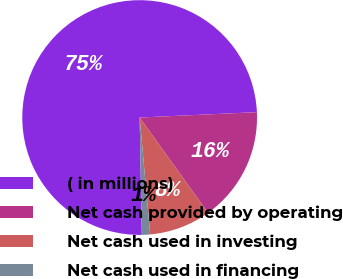Convert chart to OTSL. <chart><loc_0><loc_0><loc_500><loc_500><pie_chart><fcel>( in millions)<fcel>Net cash provided by operating<fcel>Net cash used in investing<fcel>Net cash used in financing<nl><fcel>74.56%<fcel>15.82%<fcel>8.48%<fcel>1.14%<nl></chart> 